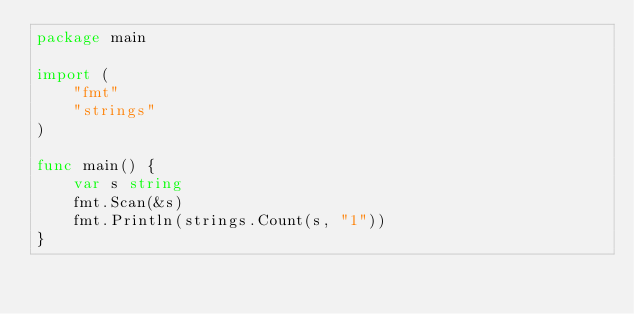Convert code to text. <code><loc_0><loc_0><loc_500><loc_500><_Go_>package main

import (
	"fmt"
	"strings"
)

func main() {
	var s string
	fmt.Scan(&s)
	fmt.Println(strings.Count(s, "1"))
}
</code> 